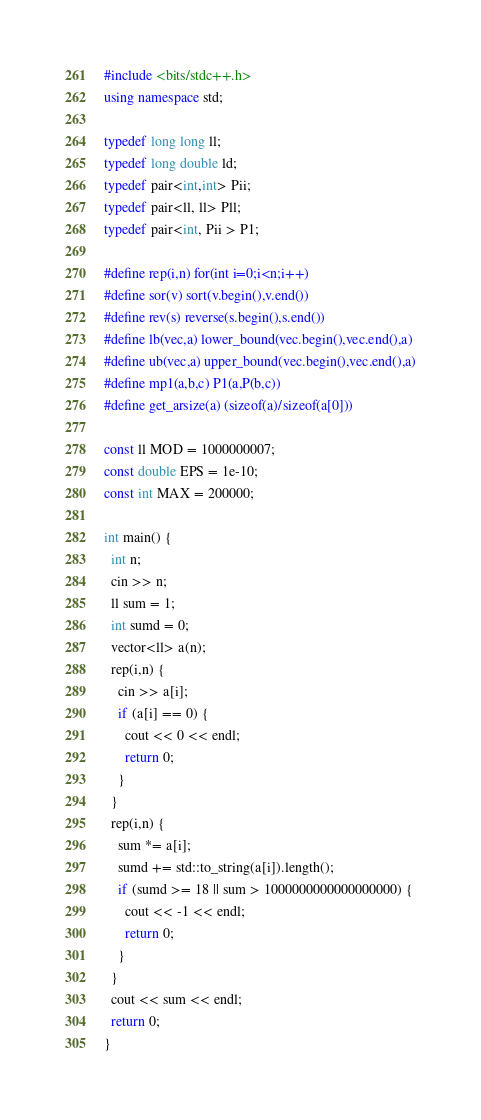<code> <loc_0><loc_0><loc_500><loc_500><_C++_>#include <bits/stdc++.h>
using namespace std;

typedef long long ll;
typedef long double ld;
typedef pair<int,int> Pii;
typedef pair<ll, ll> Pll;
typedef pair<int, Pii > P1;

#define rep(i,n) for(int i=0;i<n;i++)
#define sor(v) sort(v.begin(),v.end())
#define rev(s) reverse(s.begin(),s.end())
#define lb(vec,a) lower_bound(vec.begin(),vec.end(),a)
#define ub(vec,a) upper_bound(vec.begin(),vec.end(),a)
#define mp1(a,b,c) P1(a,P(b,c))
#define get_arsize(a) (sizeof(a)/sizeof(a[0]))

const ll MOD = 1000000007;
const double EPS = 1e-10;
const int MAX = 200000;

int main() {
  int n;
  cin >> n;
  ll sum = 1;
  int sumd = 0;
  vector<ll> a(n);
  rep(i,n) {
    cin >> a[i];
    if (a[i] == 0) {
      cout << 0 << endl;
      return 0;
    }
  }
  rep(i,n) {
    sum *= a[i];
    sumd += std::to_string(a[i]).length();
    if (sumd >= 18 || sum > 1000000000000000000) {
      cout << -1 << endl;
      return 0;
    }
  }
  cout << sum << endl;
  return 0;
}
</code> 